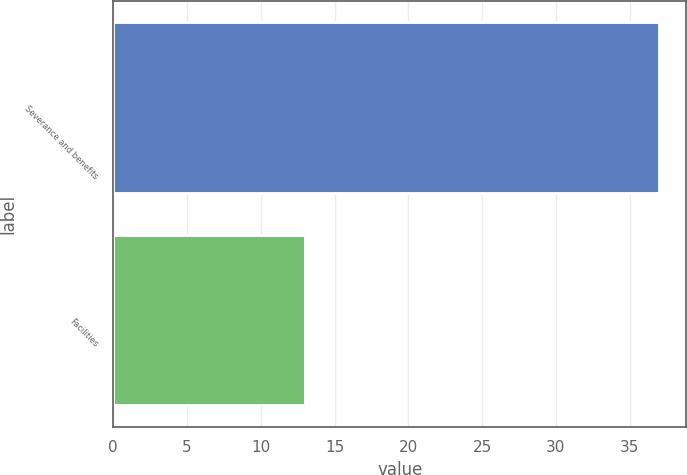Convert chart to OTSL. <chart><loc_0><loc_0><loc_500><loc_500><bar_chart><fcel>Severance and benefits<fcel>Facilities<nl><fcel>37<fcel>13<nl></chart> 